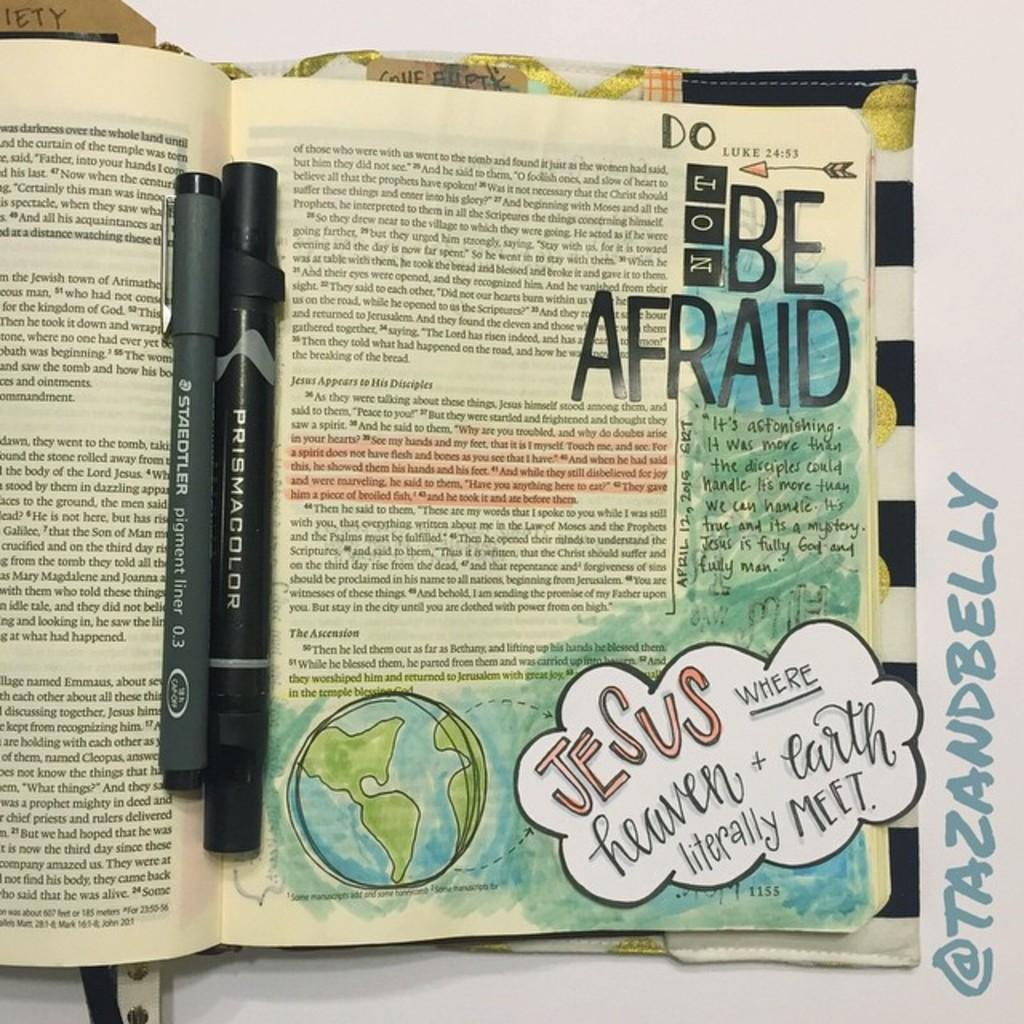<image>
Summarize the visual content of the image. An open magazine page with the words Do Not Be Afraid on top. 